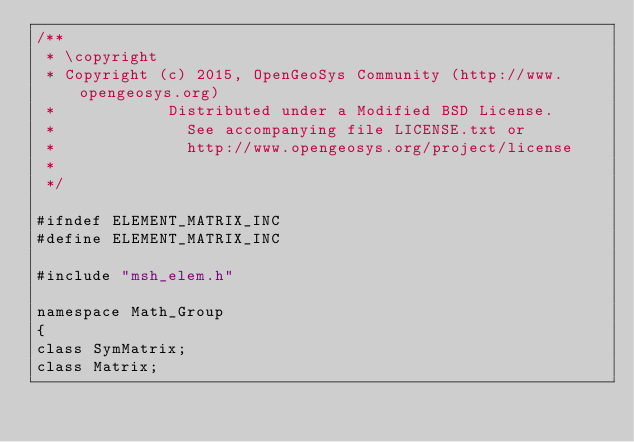Convert code to text. <code><loc_0><loc_0><loc_500><loc_500><_C_>/**
 * \copyright
 * Copyright (c) 2015, OpenGeoSys Community (http://www.opengeosys.org)
 *            Distributed under a Modified BSD License.
 *              See accompanying file LICENSE.txt or
 *              http://www.opengeosys.org/project/license
 *
 */

#ifndef ELEMENT_MATRIX_INC
#define ELEMENT_MATRIX_INC

#include "msh_elem.h"

namespace Math_Group
{
class SymMatrix;
class Matrix;</code> 